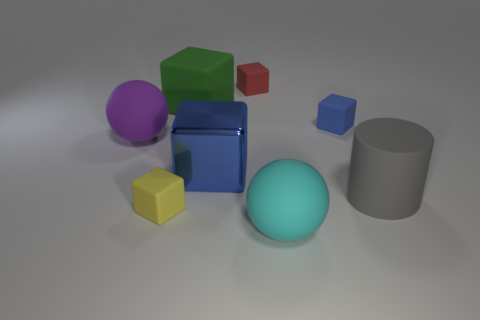Subtract all blue shiny blocks. How many blocks are left? 4 Subtract all red blocks. How many blocks are left? 4 Subtract all cyan cubes. Subtract all cyan balls. How many cubes are left? 5 Add 1 large green rubber cubes. How many objects exist? 9 Subtract all cylinders. How many objects are left? 7 Add 5 large cyan matte balls. How many large cyan matte balls are left? 6 Add 1 tiny red rubber things. How many tiny red rubber things exist? 2 Subtract 0 blue cylinders. How many objects are left? 8 Subtract all shiny cubes. Subtract all tiny blue blocks. How many objects are left? 6 